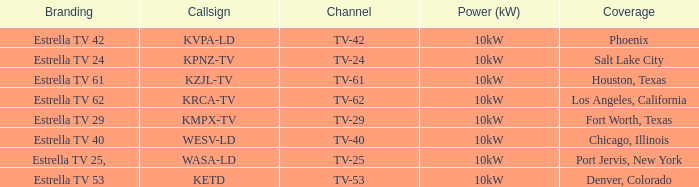Which city did kpnz-tv provide coverage for? Salt Lake City. 